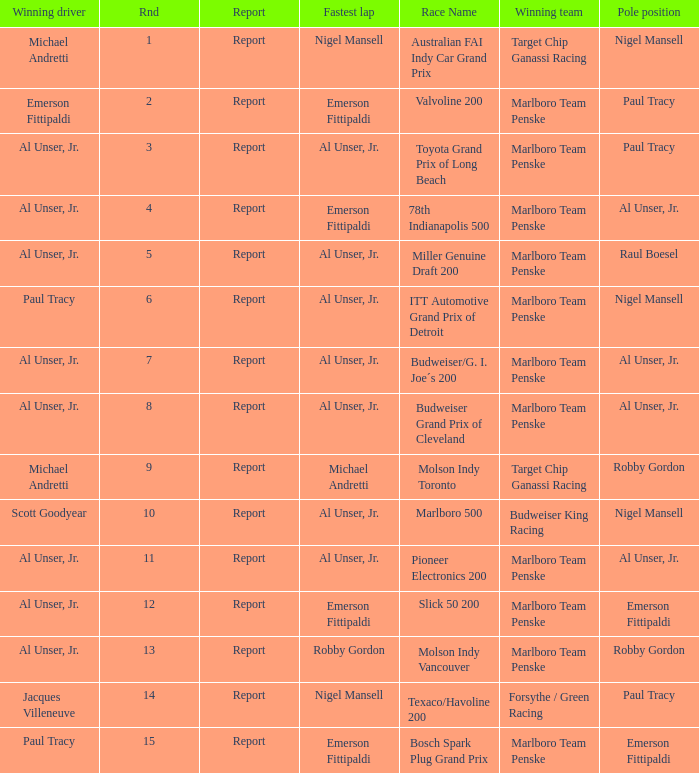What's the report of the race won by Michael Andretti, with Nigel Mansell driving the fastest lap? Report. 